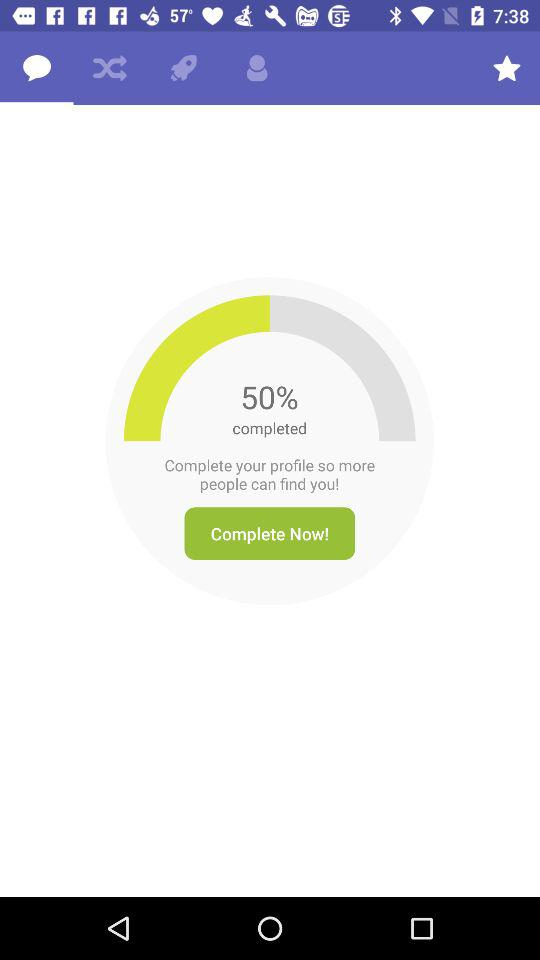What is the level of profile? The level of profile is 50% completed. 